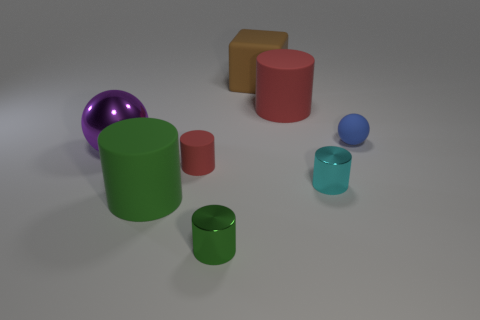Subtract 1 cylinders. How many cylinders are left? 4 Subtract all cyan cylinders. How many cylinders are left? 4 Subtract all small matte cylinders. How many cylinders are left? 4 Subtract all purple cylinders. Subtract all purple cubes. How many cylinders are left? 5 Add 2 gray cubes. How many objects exist? 10 Subtract all cylinders. How many objects are left? 3 Add 6 blocks. How many blocks exist? 7 Subtract 0 gray balls. How many objects are left? 8 Subtract all big brown cylinders. Subtract all red matte objects. How many objects are left? 6 Add 2 small cylinders. How many small cylinders are left? 5 